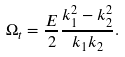<formula> <loc_0><loc_0><loc_500><loc_500>\Omega _ { t } = \frac { E } { 2 } \frac { k _ { 1 } ^ { 2 } - k _ { 2 } ^ { 2 } } { k _ { 1 } k _ { 2 } } .</formula> 